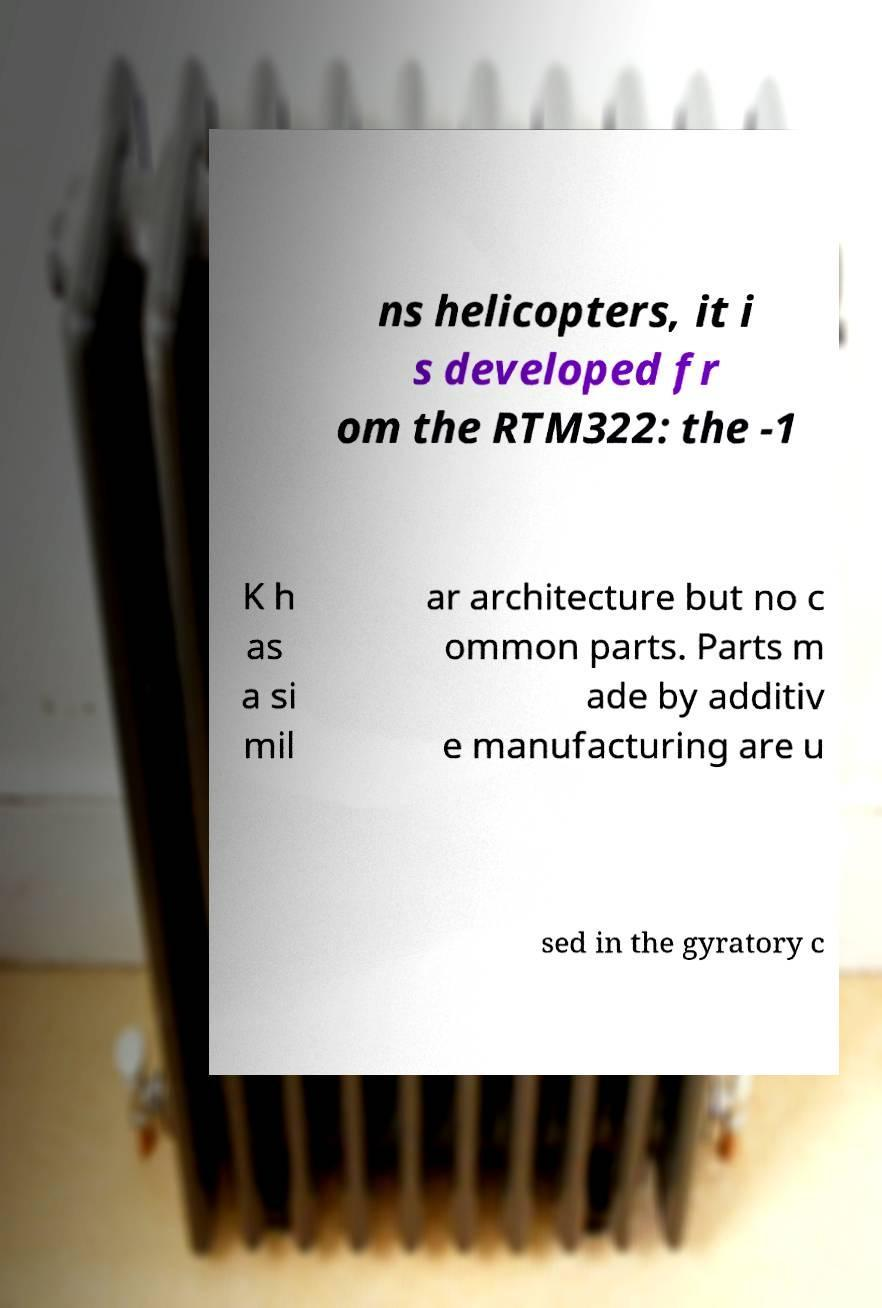Please read and relay the text visible in this image. What does it say? ns helicopters, it i s developed fr om the RTM322: the -1 K h as a si mil ar architecture but no c ommon parts. Parts m ade by additiv e manufacturing are u sed in the gyratory c 